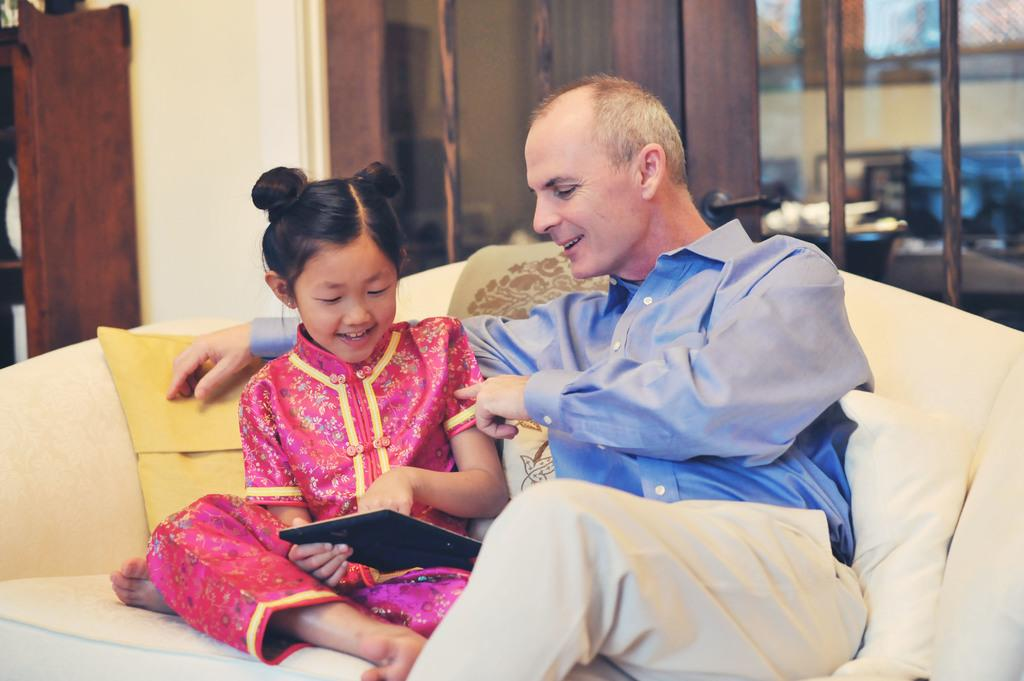Who are the people in the image? There is a man and a girl in the image. What are they doing in the image? Both the man and the girl are sitting on a sofa. What is the girl holding in her hand? The girl is holding a tab in her hand. What can be seen in the background of the image? There is a wall in the background of the image, and there is a door in the wall. What type of bottle can be seen on the sofa next to the man? There is no bottle visible on the sofa next to the man in the image. What kind of twig is the girl using to scratch her back in the image? There is no twig present in the image; the girl is holding a tab in her hand. 